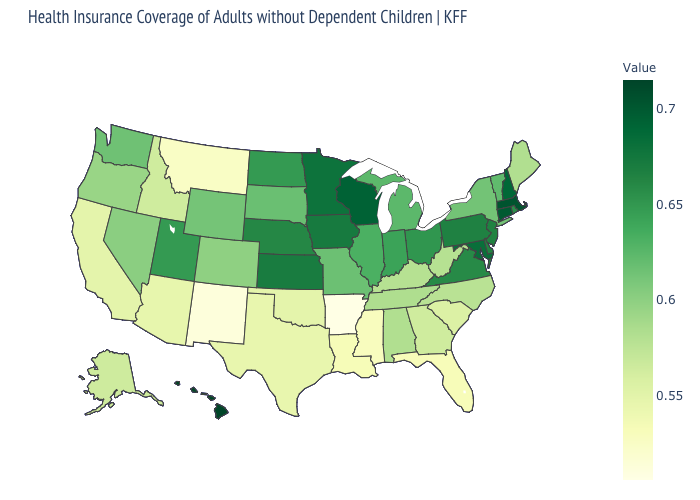Is the legend a continuous bar?
Keep it brief. Yes. Does Rhode Island have the highest value in the Northeast?
Short answer required. No. Does Tennessee have a lower value than Arizona?
Short answer required. No. Does Illinois have the lowest value in the MidWest?
Answer briefly. No. Which states have the lowest value in the USA?
Write a very short answer. Arkansas. Does Hawaii have the lowest value in the West?
Short answer required. No. 